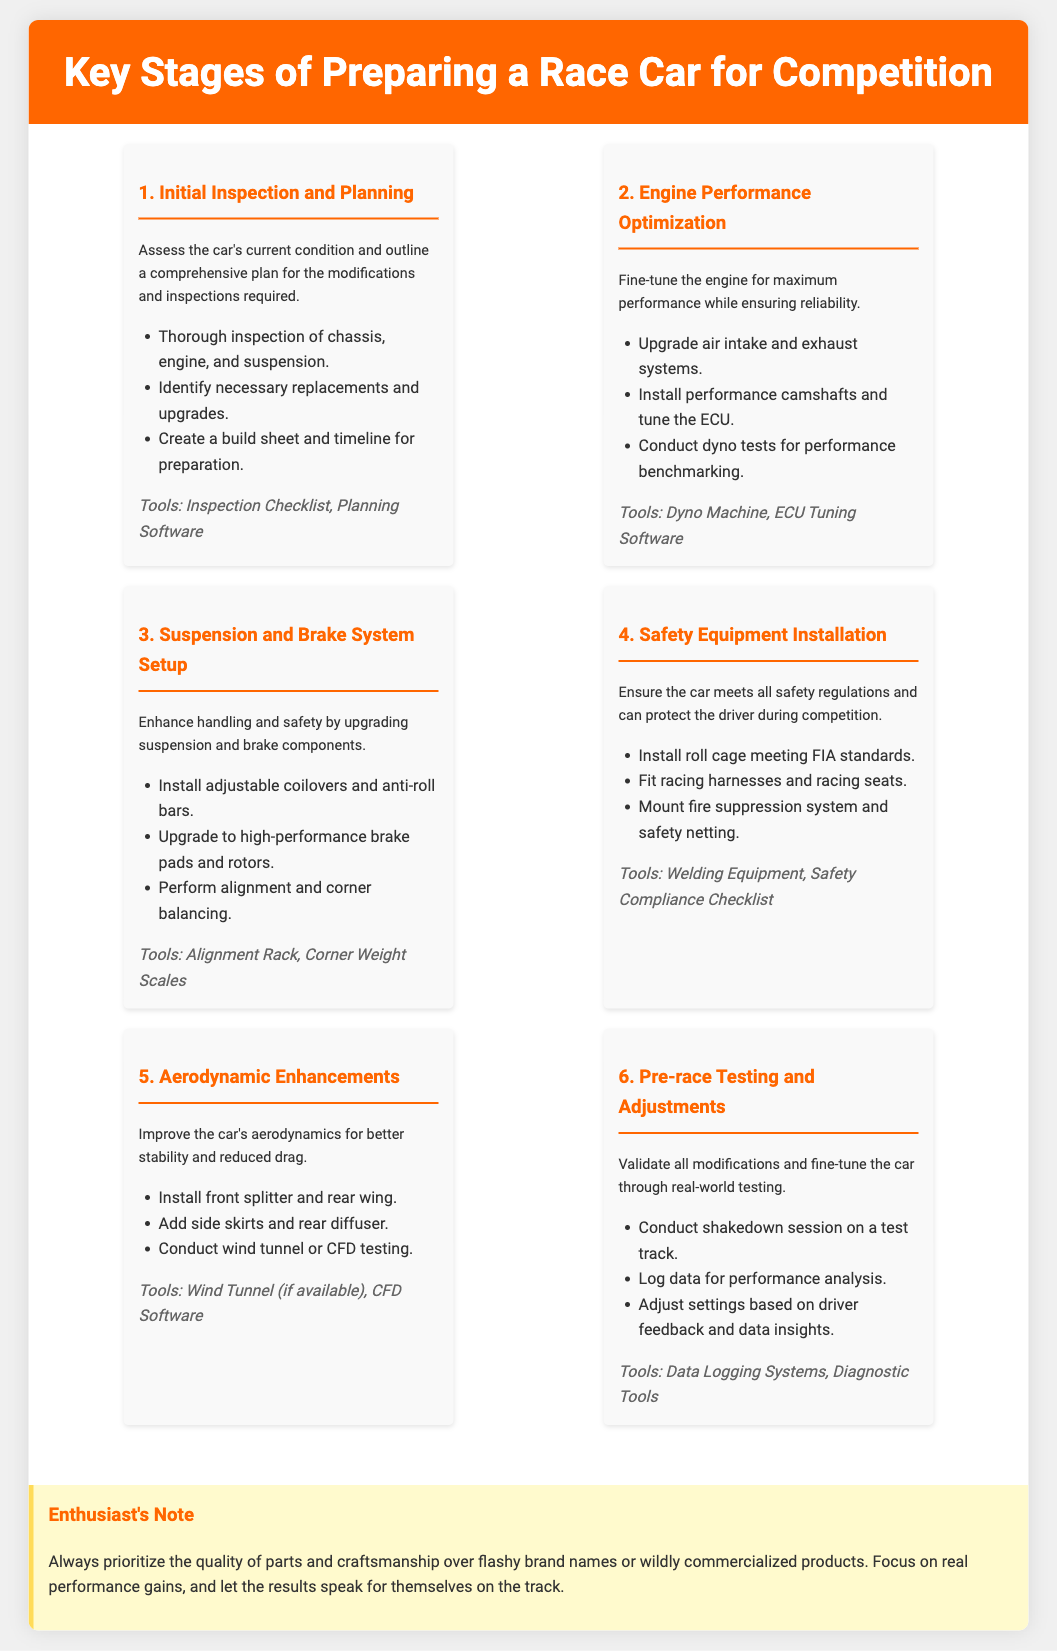What is the first stage of preparing a race car? The document lists the first stage as "Initial Inspection and Planning."
Answer: Initial Inspection and Planning What tool is mentioned for engine performance optimization? The tool listed for engine performance optimization is "Dyno Machine."
Answer: Dyno Machine How many stages are there in total? According to the document, there are six stages outlined for preparing a race car.
Answer: 6 Which stage involves improving aerodynamics? The stage focused on improving aerodynamics is "Aerodynamic Enhancements."
Answer: Aerodynamic Enhancements What is one of the tools used for safety equipment installation? For safety equipment installation, "Welding Equipment" is mentioned as a tool.
Answer: Welding Equipment In which stage do adjustments based on driver feedback occur? Adjustments based on driver feedback take place during the "Pre-race Testing and Adjustments" stage.
Answer: Pre-race Testing and Adjustments What does the enthusiast's note prioritize over commercialized products? The enthusiast's note encourages prioritizing "quality of parts and craftsmanship."
Answer: quality of parts and craftsmanship What type of testing is conducted in the aerodynamic enhancements stage? The aerodynamic enhancements stage mentions conducting "wind tunnel or CFD testing."
Answer: wind tunnel or CFD testing 